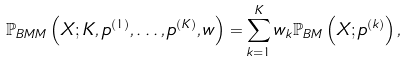Convert formula to latex. <formula><loc_0><loc_0><loc_500><loc_500>\mathbb { P } _ { B M M } \left ( X ; K , { p } ^ { \left ( 1 \right ) } , \dots , { p } ^ { \left ( K \right ) } , w \right ) = \sum _ { k = 1 } ^ { K } w _ { k } \mathbb { P } _ { B M } \left ( X ; { p } ^ { \left ( k \right ) } \right ) ,</formula> 